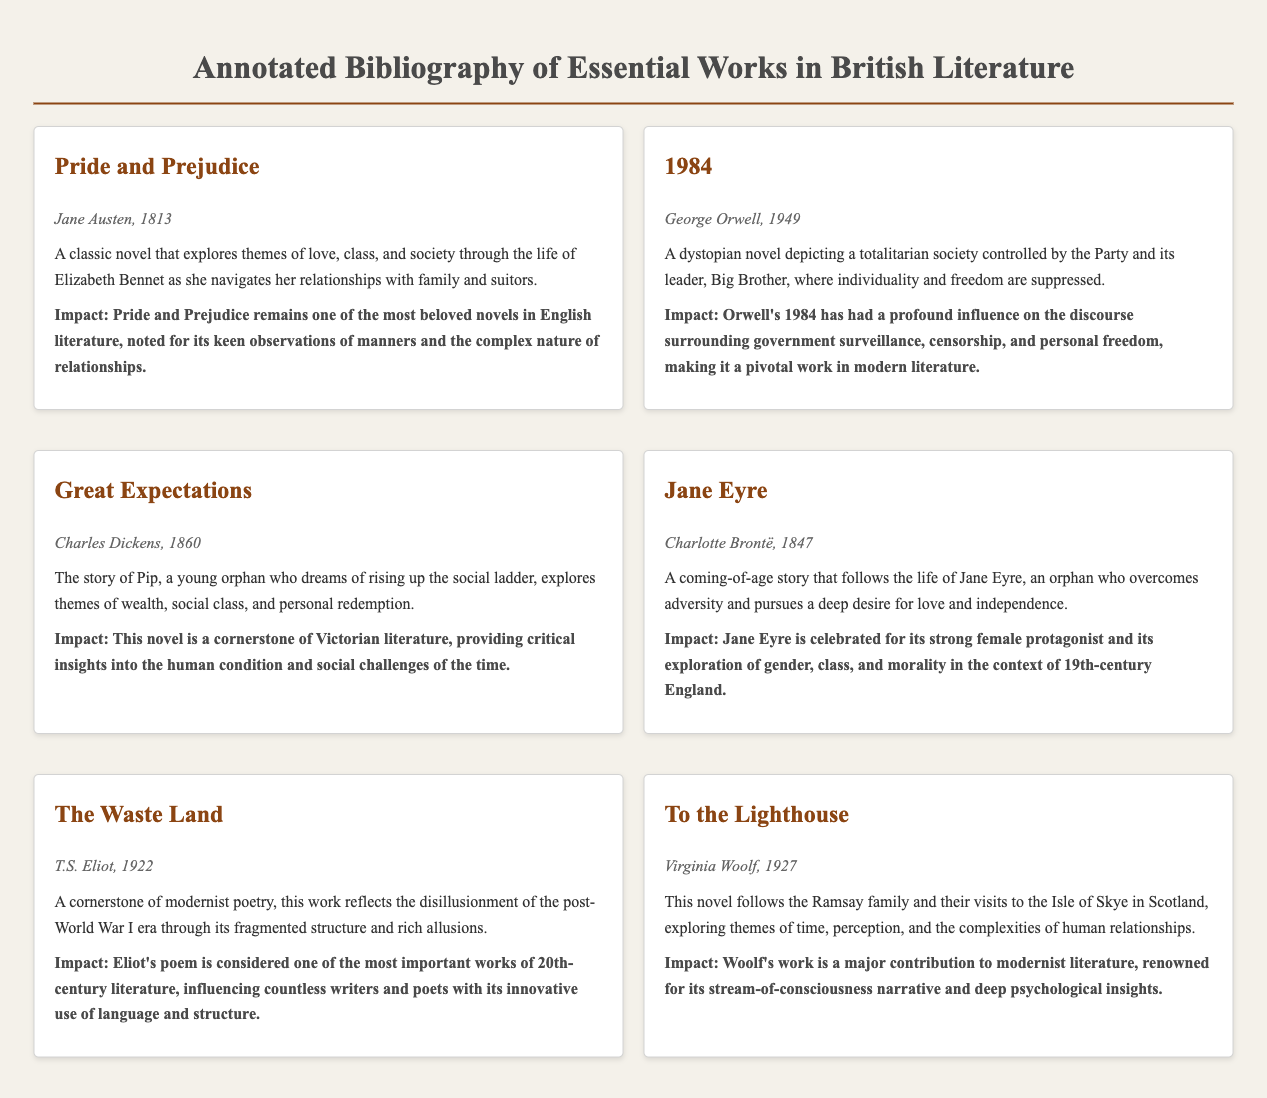What is the title of the first book listed? The first book listed in the document is identified by the title provided in a prominent position, which is "Pride and Prejudice".
Answer: Pride and Prejudice Who is the author of "1984"? The author of "1984" is mentioned directly under the title in the book info section, which states "George Orwell".
Answer: George Orwell In what year was "Jane Eyre" published? The publication year of "Jane Eyre" is specified in the book info section within the document, which states "1847".
Answer: 1847 What is the main theme explored in "To the Lighthouse"? The theme of "To the Lighthouse" is noted in the summary section, indicating exploration of "time, perception, and the complexities of human relationships".
Answer: time, perception, and the complexities of human relationships How many books are listed in total in the document? The document contains six book entries, as each entry corresponds to one essential work in British literature.
Answer: six Which author's work is noted for its strong female protagonist? The summary for "Jane Eyre" specifically highlights its focus on a "strong female protagonist", thereby identifying the author as Charlotte Brontë.
Answer: Charlotte Brontë What type of literature is "The Waste Land" considered? The impact statement for "The Waste Land" classifies it as one of the most important works in a specific genre, which is "20th-century literature".
Answer: 20th-century literature What notable societal theme does "1984" address? The summary for "1984" describes a dystopian society where "individuality and freedom are suppressed," indicating the societal theme it addresses.
Answer: government surveillance, censorship, and personal freedom 